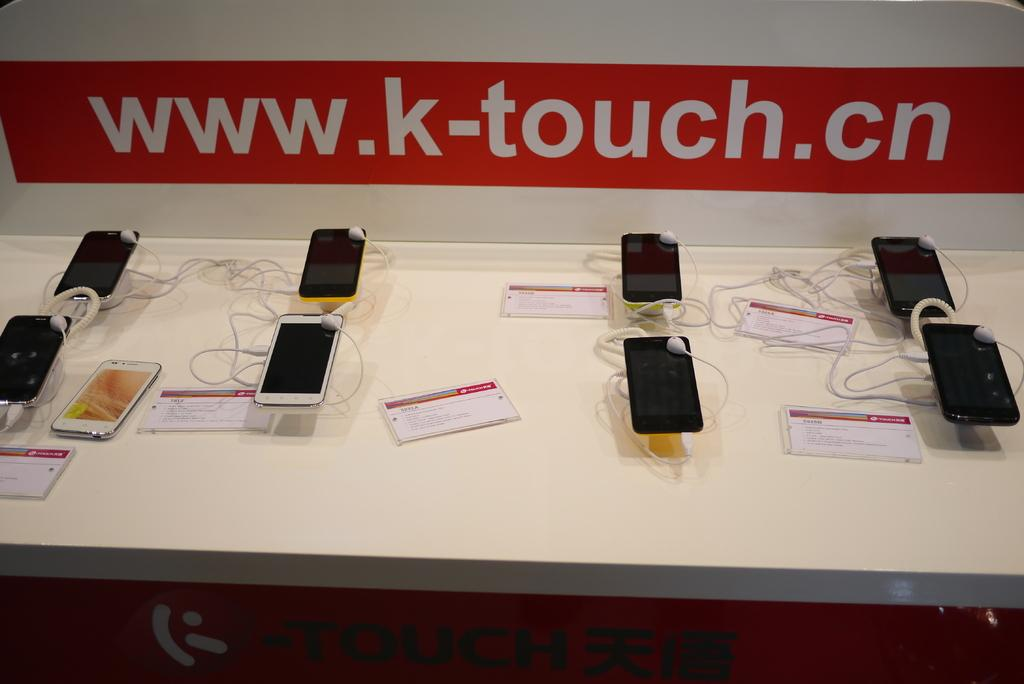<image>
Present a compact description of the photo's key features. Several phones are displayed for sale under a sign that says www.k-touch.cn 